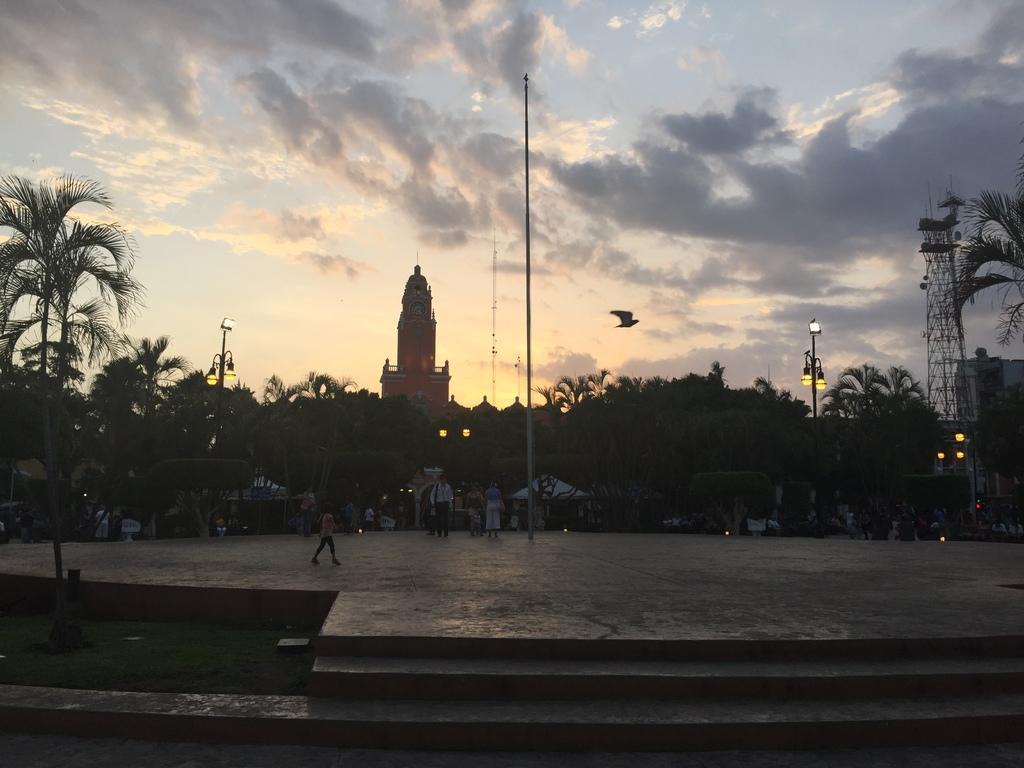Can you describe this image briefly? In the image there is a pavement in the foreground, on that there are few people and around the pavement there are lights, trees and in the background there is a clock tower. 